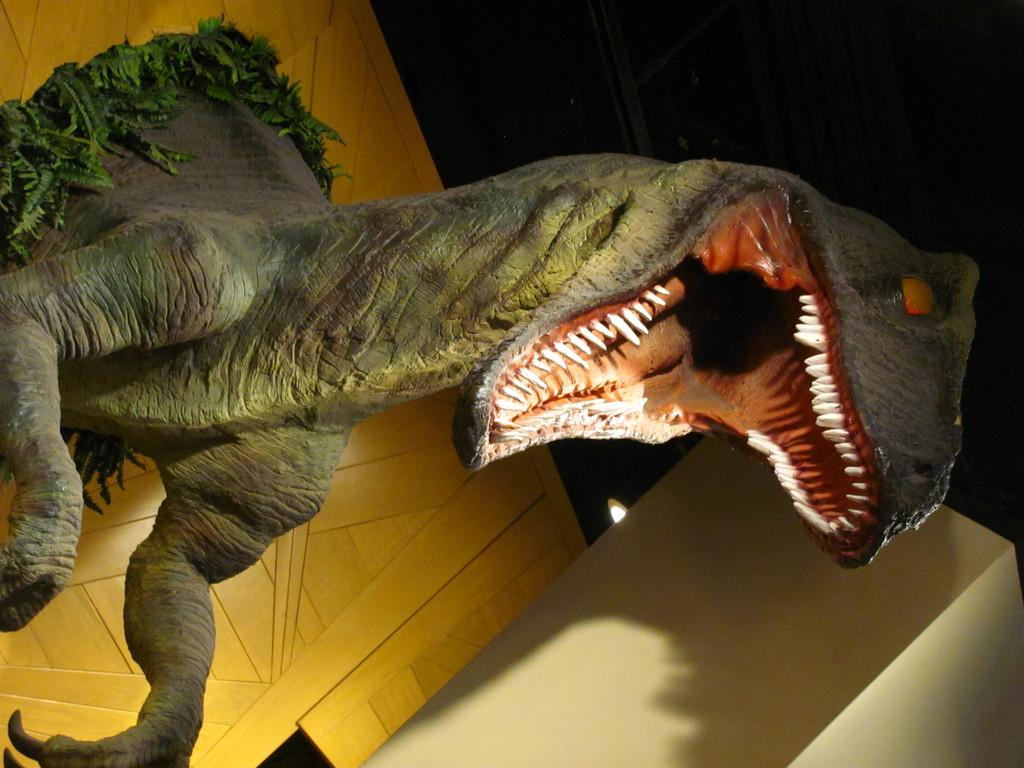What is the main subject of the image? There is a statue of a dinosaur in the image. How is the dinosaur statue positioned in the image? The statue is attached to the wall. What can be seen in the bottom right corner of the image? The bottom right of the image contains a wall. What type of summer clothing is the daughter wearing in the image? There is no daughter or summer clothing present in the image; it features a dinosaur statue attached to a wall. 